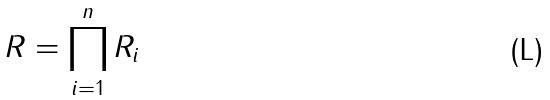Convert formula to latex. <formula><loc_0><loc_0><loc_500><loc_500>R = \prod _ { i = 1 } ^ { n } R _ { i }</formula> 